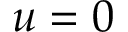<formula> <loc_0><loc_0><loc_500><loc_500>u = 0</formula> 